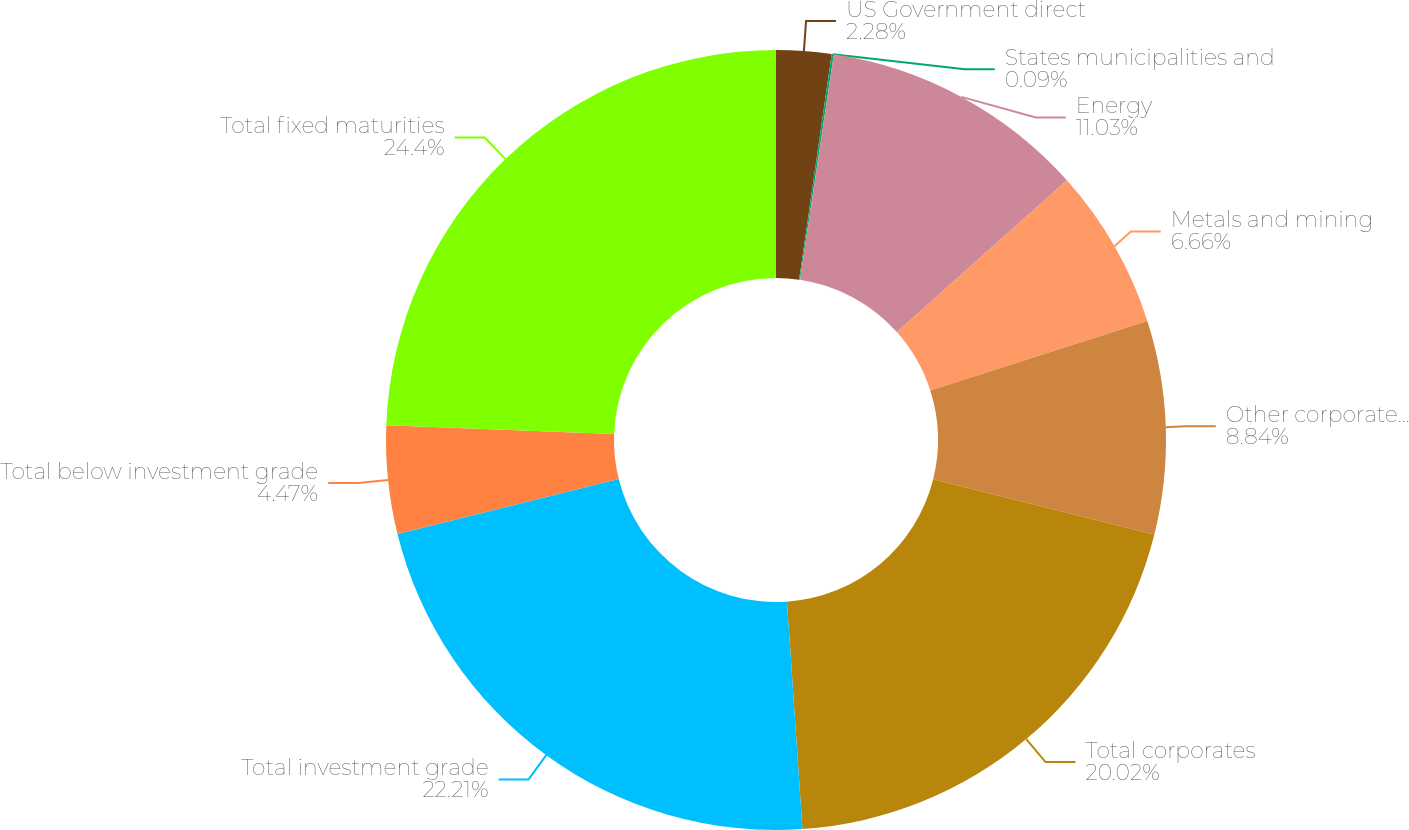Convert chart. <chart><loc_0><loc_0><loc_500><loc_500><pie_chart><fcel>US Government direct<fcel>States municipalities and<fcel>Energy<fcel>Metals and mining<fcel>Other corporate sectors<fcel>Total corporates<fcel>Total investment grade<fcel>Total below investment grade<fcel>Total fixed maturities<nl><fcel>2.28%<fcel>0.09%<fcel>11.03%<fcel>6.66%<fcel>8.84%<fcel>20.02%<fcel>22.21%<fcel>4.47%<fcel>24.4%<nl></chart> 